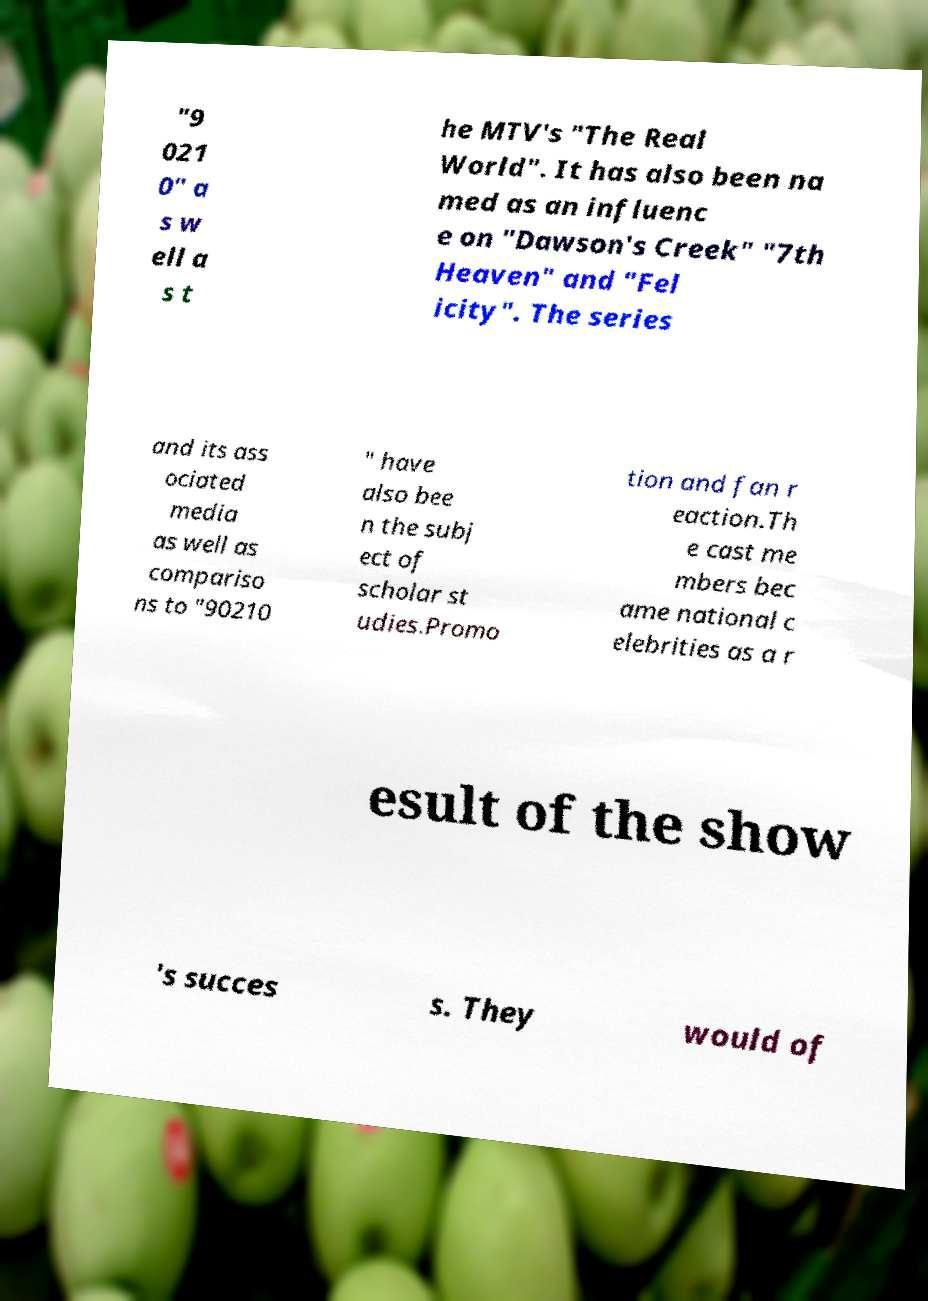For documentation purposes, I need the text within this image transcribed. Could you provide that? "9 021 0" a s w ell a s t he MTV's "The Real World". It has also been na med as an influenc e on "Dawson's Creek" "7th Heaven" and "Fel icity". The series and its ass ociated media as well as compariso ns to "90210 " have also bee n the subj ect of scholar st udies.Promo tion and fan r eaction.Th e cast me mbers bec ame national c elebrities as a r esult of the show 's succes s. They would of 